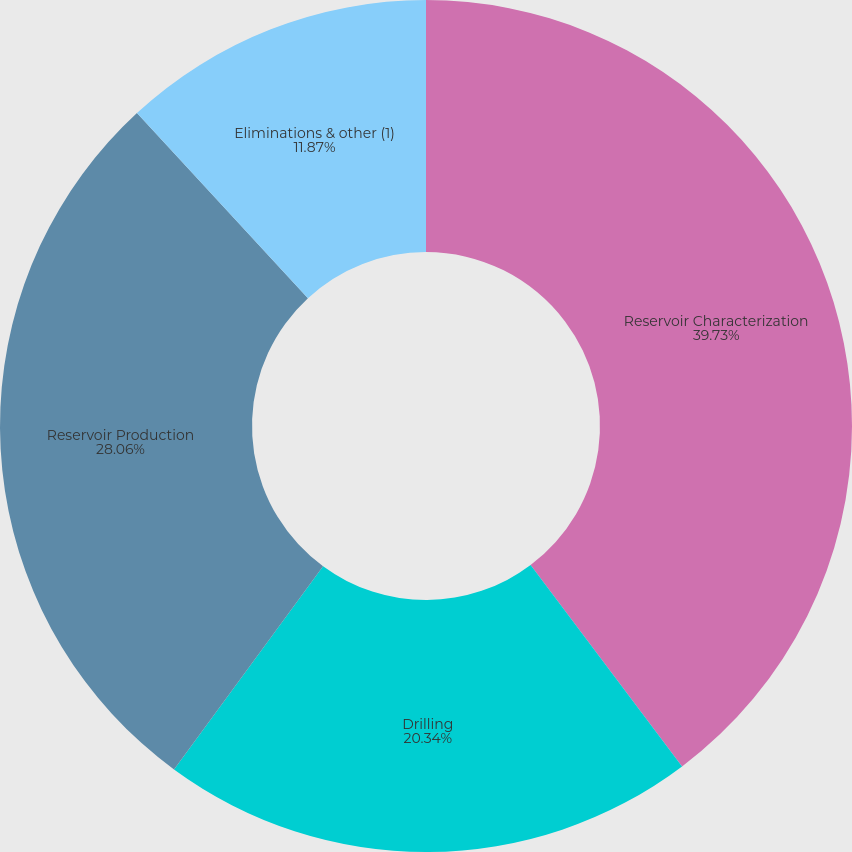<chart> <loc_0><loc_0><loc_500><loc_500><pie_chart><fcel>Reservoir Characterization<fcel>Drilling<fcel>Reservoir Production<fcel>Eliminations & other (1)<nl><fcel>39.74%<fcel>20.34%<fcel>28.06%<fcel>11.87%<nl></chart> 